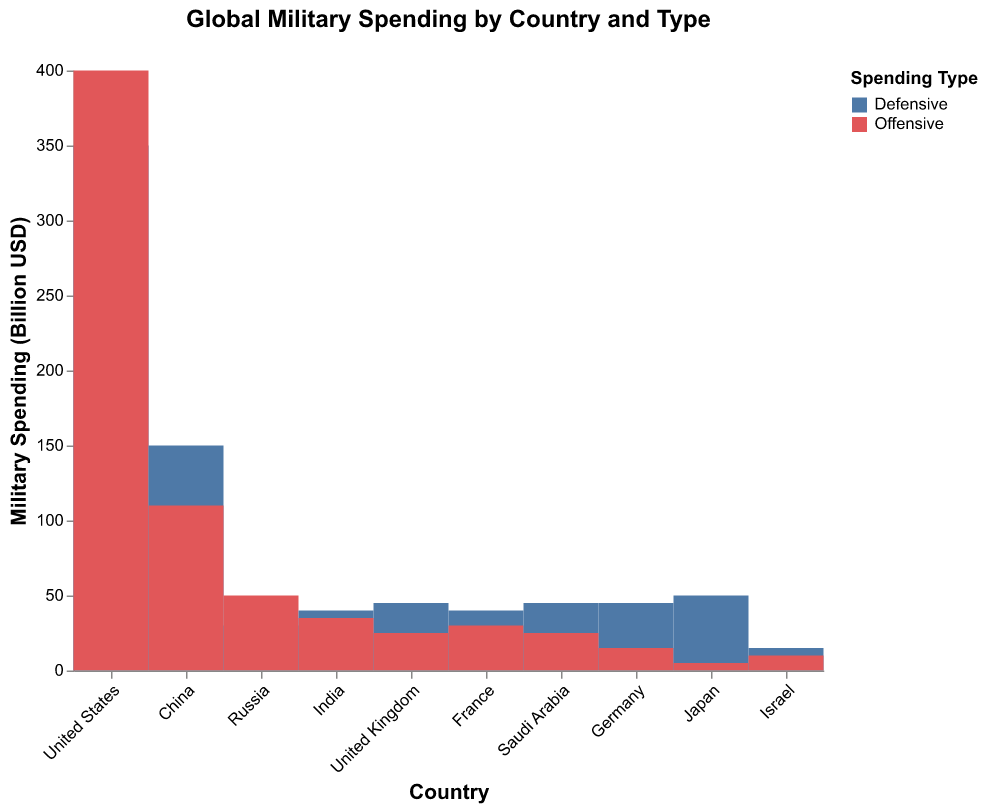What is the total military spending of the United States? The United States has defensive and offensive expenditures of 350 billion USD and 400 billion USD, respectively. The total is 350 + 400 = 750 billion USD.
Answer: 750 billion USD Which country has the highest defensive military spending? The United States has the highest defensive expenditure at 350 billion USD.
Answer: United States Which country spends more on offensive military expenditures, India or Russia? India spends 35 billion USD on offensive expenditures, while Russia spends 50 billion USD. Therefore, Russia spends more.
Answer: Russia What is the difference between defensive and offensive spending in Germany? Germany spends 45 billion USD on defensive and 15 billion USD on offensive expenditures. The difference is 45 - 15 = 30 billion USD.
Answer: 30 billion USD What is the combined military spending of China? China spends 150 billion USD on defensive and 110 billion USD on offensive expenditures. The total is 150 + 110 = 260 billion USD.
Answer: 260 billion USD How does the defensive spending of Israel compare to Japan? Israel spends 15 billion USD on defensive, while Japan spends 50 billion USD. Hence, Japan spends more.
Answer: Japan Which country has the smallest offensive military spending? Japan has the smallest offensive expenditure at 5 billion USD.
Answer: Japan What is the ratio of offensive to defensive spending in the United Kingdom? The United Kingdom spends 25 billion USD on offensive and 45 billion USD on defensive. The ratio is 25/45 = 5/9.
Answer: 5/9 What is the total spending of Saudi Arabia? Saudi Arabia spends 45 billion USD on defensive and 25 billion USD on offensive. The total is 45 + 25 = 70 billion USD.
Answer: 70 billion USD Among the listed countries, which one has the highest overall military spending? The United States has the highest overall military spending at 750 billion USD.
Answer: United States 